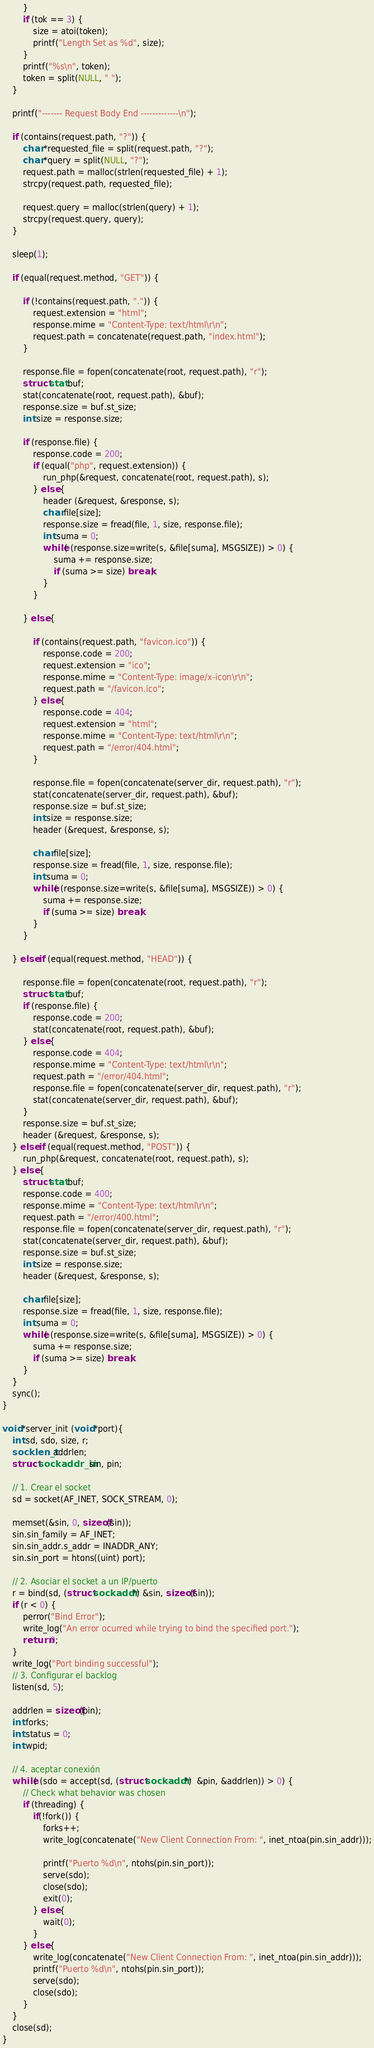<code> <loc_0><loc_0><loc_500><loc_500><_C_>		}
		if (tok == 3) {
			size = atoi(token);
			printf("Length Set as %d", size);
		}
		printf("%s\n", token);
		token = split(NULL, " ");
	}

	printf("------- Request Body End -------------\n");

	if (contains(request.path, "?")) {
		char *requested_file = split(request.path, "?");
		char *query = split(NULL, "?");
		request.path = malloc(strlen(requested_file) + 1);
		strcpy(request.path, requested_file);

		request.query = malloc(strlen(query) + 1);
		strcpy(request.query, query);
	}

    sleep(1);

	if (equal(request.method, "GET")) {

		if (!contains(request.path, ".")) {
			request.extension = "html";
			response.mime = "Content-Type: text/html\r\n";
			request.path = concatenate(request.path, "index.html");
		}

		response.file = fopen(concatenate(root, request.path), "r");
		struct stat buf;
		stat(concatenate(root, request.path), &buf);
		response.size = buf.st_size;
		int size = response.size;

		if (response.file) {
			response.code = 200;
			if (equal("php", request.extension)) {
				run_php(&request, concatenate(root, request.path), s);
			} else {
				header (&request, &response, s);
				char file[size];
				response.size = fread(file, 1, size, response.file);
				int suma = 0;
				while( (response.size=write(s, &file[suma], MSGSIZE)) > 0) {
					suma += response.size;
					if (suma >= size) break;
				}
			}

		} else {

			if (contains(request.path, "favicon.ico")) {
				response.code = 200;
				request.extension = "ico";
				response.mime = "Content-Type: image/x-icon\r\n";
				request.path = "/favicon.ico";
			} else {
				response.code = 404;
				request.extension = "html";
				response.mime = "Content-Type: text/html\r\n";
				request.path = "/error/404.html";
			}

			response.file = fopen(concatenate(server_dir, request.path), "r");
			stat(concatenate(server_dir, request.path), &buf);
			response.size = buf.st_size;
			int size = response.size;
			header (&request, &response, s);

			char file[size];
			response.size = fread(file, 1, size, response.file);
			int suma = 0;
			while( (response.size=write(s, &file[suma], MSGSIZE)) > 0) {
				suma += response.size;
				if (suma >= size) break;
			}
		}

	} else if (equal(request.method, "HEAD")) {

		response.file = fopen(concatenate(root, request.path), "r");
		struct stat buf;
		if (response.file) {
			response.code = 200;
			stat(concatenate(root, request.path), &buf);
		} else {
			response.code = 404;
			response.mime = "Content-Type: text/html\r\n";
			request.path = "/error/404.html";
			response.file = fopen(concatenate(server_dir, request.path), "r");
			stat(concatenate(server_dir, request.path), &buf);
		}
		response.size = buf.st_size;
		header (&request, &response, s);
	} else if (equal(request.method, "POST")) {
		run_php(&request, concatenate(root, request.path), s);
	} else {
		struct stat buf;
		response.code = 400;
		response.mime = "Content-Type: text/html\r\n";
		request.path = "/error/400.html";
		response.file = fopen(concatenate(server_dir, request.path), "r");
		stat(concatenate(server_dir, request.path), &buf);
		response.size = buf.st_size;
		int size = response.size;
		header (&request, &response, s);

		char file[size];
		response.size = fread(file, 1, size, response.file);
		int suma = 0;
		while( (response.size=write(s, &file[suma], MSGSIZE)) > 0) {
			suma += response.size;
			if (suma >= size) break;
		}
	}
    sync();
}

void *server_init (void *port){
	int sd, sdo, size, r;
	socklen_t addrlen;
    struct sockaddr_in sin, pin;

    // 1. Crear el socket
    sd = socket(AF_INET, SOCK_STREAM, 0);

    memset(&sin, 0, sizeof(sin));
    sin.sin_family = AF_INET;
    sin.sin_addr.s_addr = INADDR_ANY;
    sin.sin_port = htons((uint) port);

    // 2. Asociar el socket a un IP/puerto
    r = bind(sd, (struct sockaddr *) &sin, sizeof(sin));
	if (r < 0) {
		perror("Bind Error");
		write_log("An error ocurred while trying to bind the specified port.");
		return 0;
	}
	write_log("Port binding successful");
    // 3. Configurar el backlog
    listen(sd, 5);

    addrlen = sizeof(pin);
	int forks;
	int status = 0;
	int wpid;

	// 4. aceptar conexión
    while( (sdo = accept(sd, (struct sockaddr *)  &pin, &addrlen)) > 0) {
		// Check what behavior was chosen
		if (threading) {
			if(!fork()) {
				forks++;
				write_log(concatenate("New Client Connection From: ", inet_ntoa(pin.sin_addr)));

		        printf("Puerto %d\n", ntohs(pin.sin_port));
				serve(sdo);
		        close(sdo);
				exit(0);
		    } else {
				wait(0);
			}
		} else {
			write_log(concatenate("New Client Connection From: ", inet_ntoa(pin.sin_addr)));
	        printf("Puerto %d\n", ntohs(pin.sin_port));
			serve(sdo);
	        close(sdo);
		}
	}
    close(sd);
}</code> 